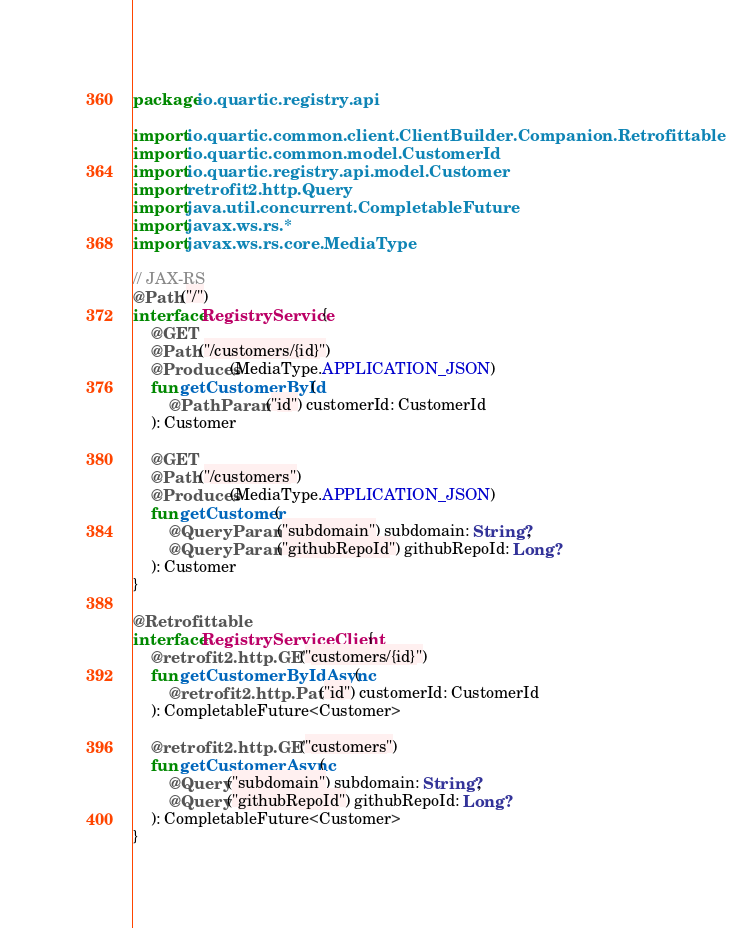Convert code to text. <code><loc_0><loc_0><loc_500><loc_500><_Kotlin_>package io.quartic.registry.api

import io.quartic.common.client.ClientBuilder.Companion.Retrofittable
import io.quartic.common.model.CustomerId
import io.quartic.registry.api.model.Customer
import retrofit2.http.Query
import java.util.concurrent.CompletableFuture
import javax.ws.rs.*
import javax.ws.rs.core.MediaType

// JAX-RS
@Path("/")
interface RegistryService {
    @GET
    @Path("/customers/{id}")
    @Produces(MediaType.APPLICATION_JSON)
    fun getCustomerById(
        @PathParam("id") customerId: CustomerId
    ): Customer

    @GET
    @Path("/customers")
    @Produces(MediaType.APPLICATION_JSON)
    fun getCustomer(
        @QueryParam("subdomain") subdomain: String?,
        @QueryParam("githubRepoId") githubRepoId: Long?
    ): Customer
}

@Retrofittable
interface RegistryServiceClient {
    @retrofit2.http.GET("customers/{id}")
    fun getCustomerByIdAsync(
        @retrofit2.http.Path("id") customerId: CustomerId
    ): CompletableFuture<Customer>

    @retrofit2.http.GET("customers")
    fun getCustomerAsync(
        @Query("subdomain") subdomain: String?,
        @Query("githubRepoId") githubRepoId: Long?
    ): CompletableFuture<Customer>
}
</code> 